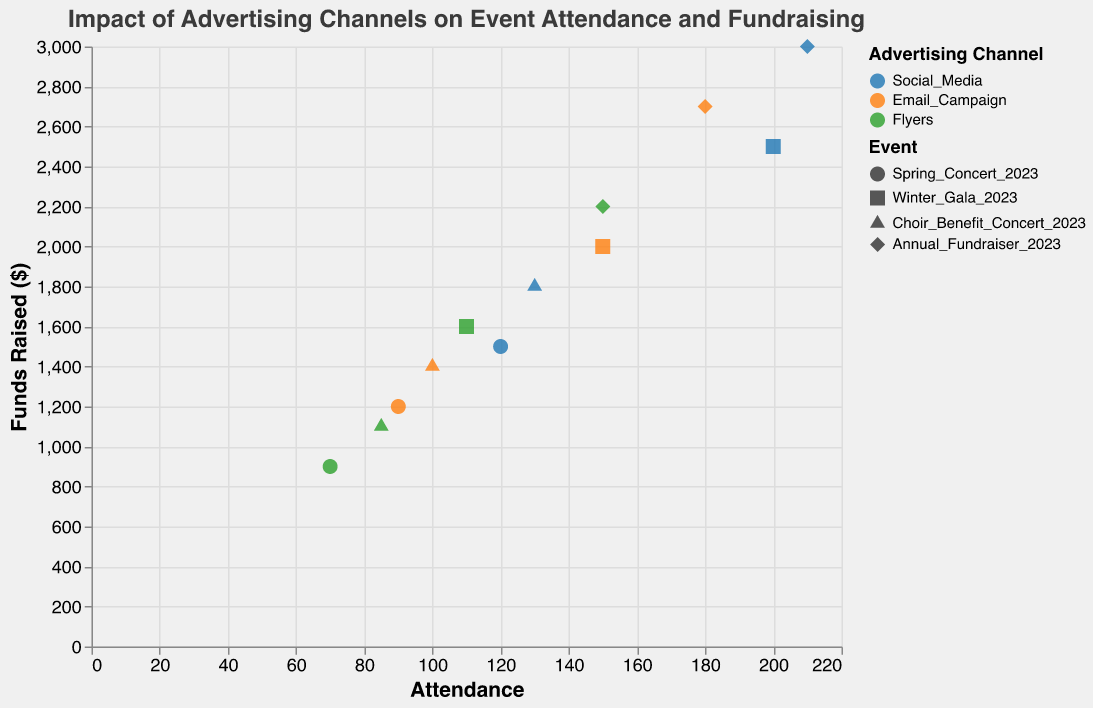What is the title of the figure? The title of the figure is displayed at the top and reads "Impact of Advertising Channels on Event Attendance and Fundraising".
Answer: Impact of Advertising Channels on Event Attendance and Fundraising What are the advertising channels represented in the plot? The advertising channels are denoted by different colors in the legend, which are Social Media (blue), Email Campaign (orange), and Flyers (green).
Answer: Social Media, Email Campaign, Flyers Which event had the highest attendance and how many attended? By observing the attendance axis and the shapes representing different events, the event with the highest attendance is the Annual Fundraiser 2023, which had 210 attendees.
Answer: Annual Fundraiser 2023, 210 How many data points are visible in the plot? Each combination of Event and Advertising Channel is a data point. There are 4 events and 3 advertising channels, leading to 4*3 = 12 data points. Inspecting the plot confirms this count.
Answer: 12 Which advertising channel was the least effective in raising funds for the Winter Gala 2023? Winter Gala 2023 is represented by the square shapes. Among these, the squares indicating Flyers raised the least funds, totaling $1600.
Answer: Flyers For the Spring Concert 2023, what is the total amount of funds raised through all advertising channels? Summing the funds raised for Social Media ($1500), Email Campaign ($1200), and Flyers ($900) for Spring Concert 2023: 1500 + 1200 + 900 = $3600.
Answer: $3600 Comparing the Flyers advertising channel, which event saw the highest funds raised? By comparing the green data points (Flyers) across events, the Annual Fundraiser 2023 raised the most funds: $2200.
Answer: Annual Fundraiser 2023 What is the average attendance for the Email Campaigns across all events? Summing the attendance for Email Campaign across all events (90, 150, 100, 180) and dividing by the number of events (4): (90 + 150 + 100 + 180) / 4 = 130.
Answer: 130 Which advertising channel had the highest attendance for the Choir Benefit Concert 2023 and by how much? For Choir Benefit Concert 2023, checking the attendance for different colors: Social Media (130), Email Campaign (100), and Flyers (85). Social Media had the highest attendance with 130.
Answer: Social Media, 130 Is there a correlation between attendance and funds raised for the Annual Fundraiser 2023? For the Annual Fundraiser 2023 (diamond shapes), there is a pattern where higher attendance generally corresponds to higher funds raised, indicating a positive correlation.
Answer: Yes 